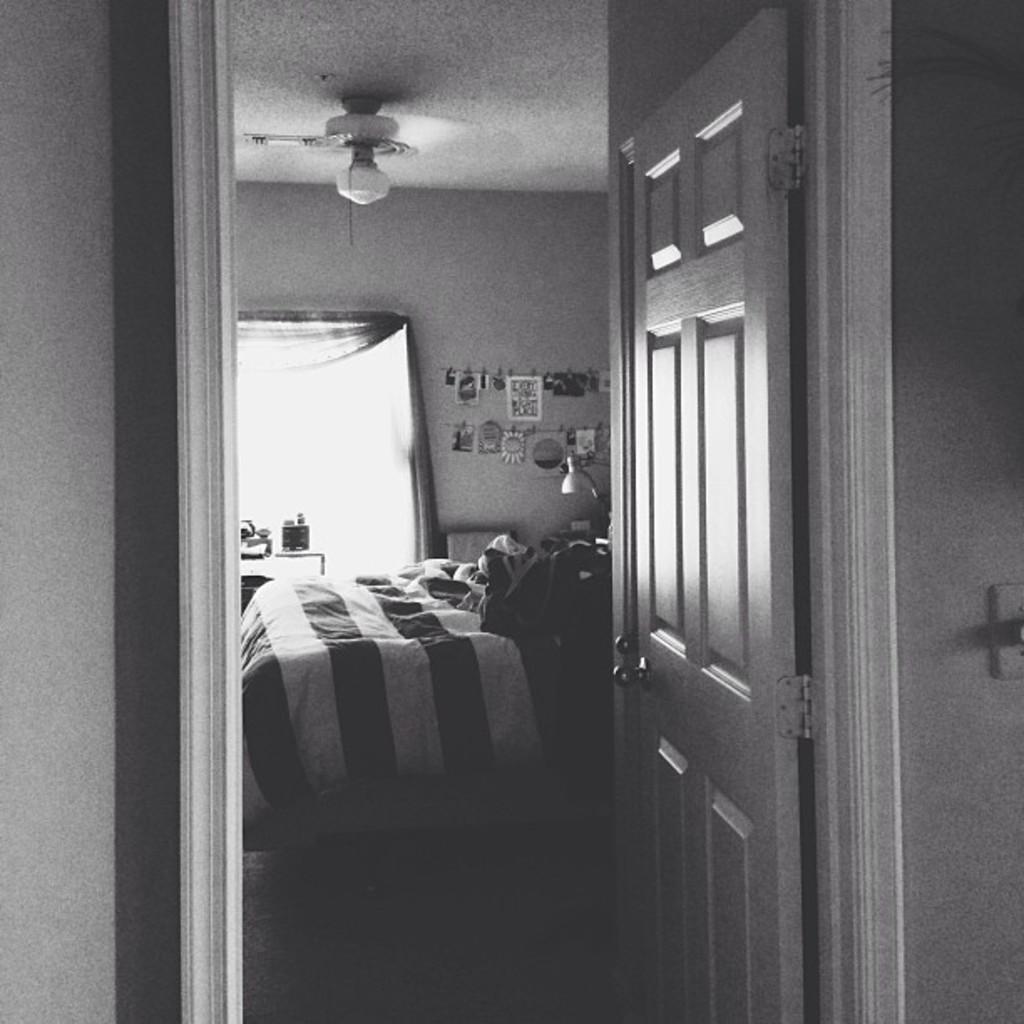Please provide a concise description of this image. In this image there is a wall and a door of a room. In the room there is a bed and few clothes on it, behind that there is a lamp and few objects are hanging on the wall, there is a window and curtains, in front of that there are few objects on the table. At the top of the image there is a fan and a ceiling. 